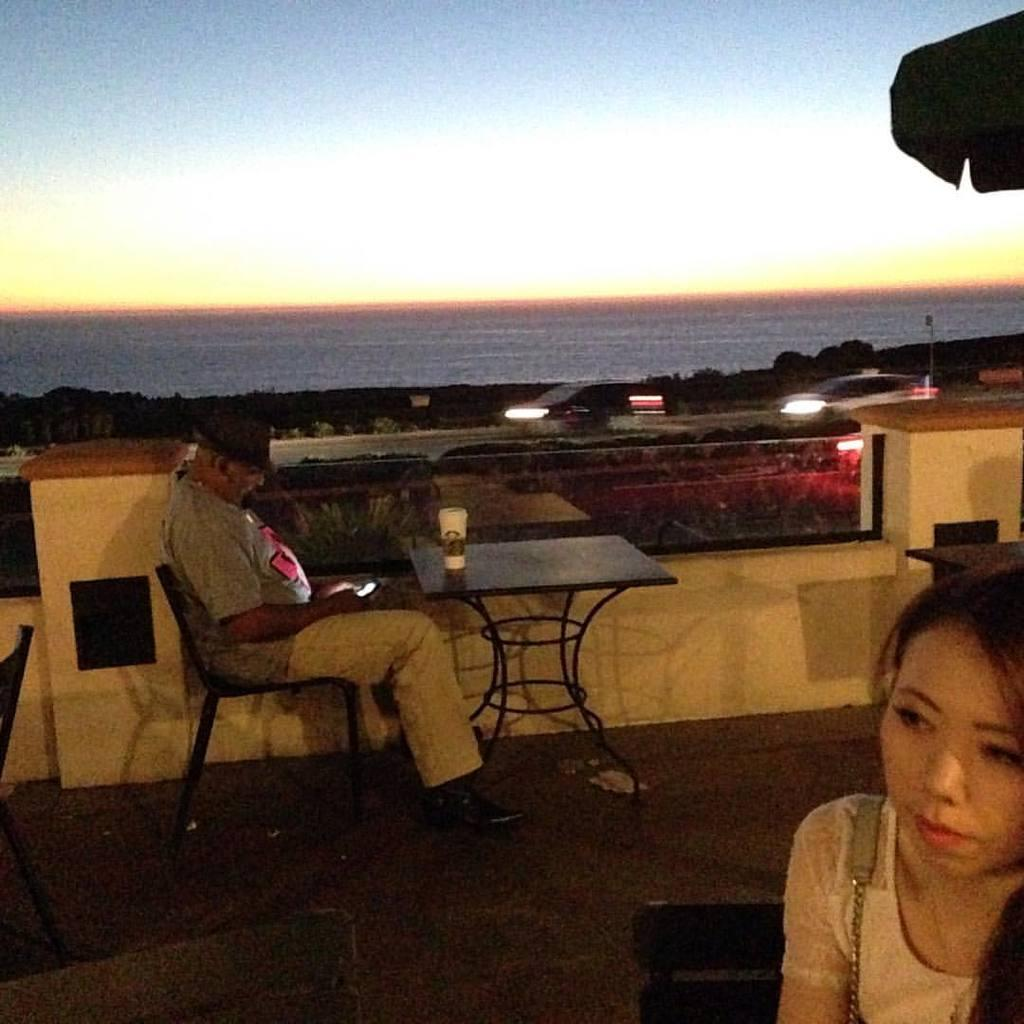What is the man in the image doing? The man is sitting on a chair in the image. What is in front of the man? There is a table in front of the man. What is located beside the man? There is a road beside the man. What can be seen in the distance in the image? There is a sea visible in the image. What type of vessel is the man using to process cherries in the image? There is no vessel or cherries present in the image, and no process is being performed by the man. 